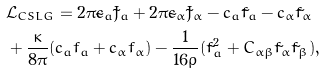<formula> <loc_0><loc_0><loc_500><loc_500>& \mathcal { L } _ { C S L G } = 2 \pi \tilde { c } _ { a } \tilde { J } _ { a } + 2 \pi \tilde { c } _ { \alpha } \tilde { J } _ { \alpha } - c _ { a } \tilde { f } _ { a } - c _ { \alpha } \tilde { f } _ { \alpha } \\ & + \frac { \kappa } { 8 \pi } ( c _ { a } f _ { a } + c _ { \alpha } f _ { \alpha } ) - \frac { 1 } { 1 6 \rho } ( \tilde { f } _ { a } ^ { 2 } + C _ { \alpha \beta } \tilde { f } _ { \alpha } \tilde { f } _ { \beta } ) ,</formula> 